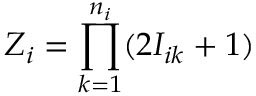Convert formula to latex. <formula><loc_0><loc_0><loc_500><loc_500>Z _ { i } = \prod _ { k = 1 } ^ { n _ { i } } ( 2 I _ { i k } + 1 )</formula> 